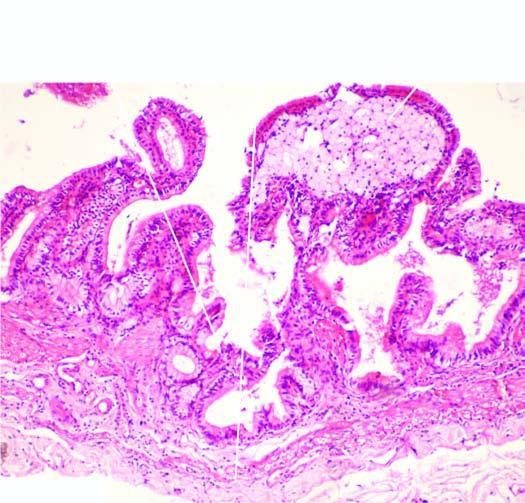what does the lamina propria of the mucosa show?
Answer the question using a single word or phrase. Foamy macrophages 